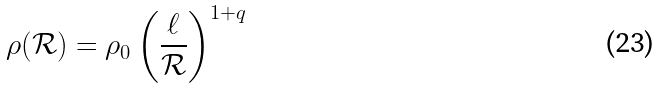Convert formula to latex. <formula><loc_0><loc_0><loc_500><loc_500>\rho ( \mathcal { R } ) = \rho _ { 0 } \left ( \frac { \ell } { \mathcal { R } } \right ) ^ { 1 + q }</formula> 